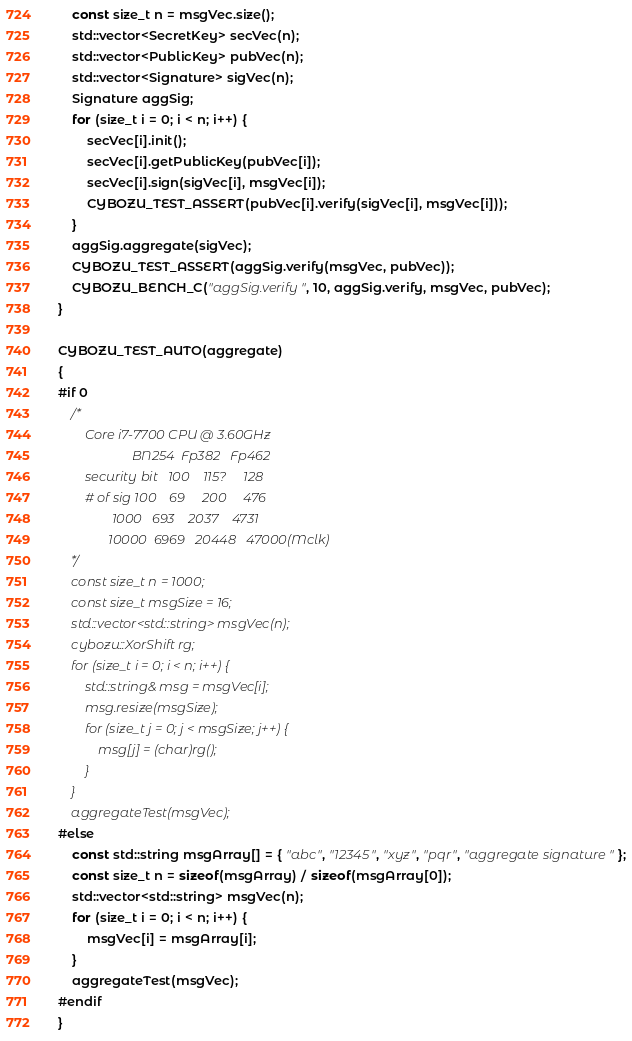<code> <loc_0><loc_0><loc_500><loc_500><_C++_>	const size_t n = msgVec.size();
	std::vector<SecretKey> secVec(n);
	std::vector<PublicKey> pubVec(n);
	std::vector<Signature> sigVec(n);
	Signature aggSig;
	for (size_t i = 0; i < n; i++) {
		secVec[i].init();
		secVec[i].getPublicKey(pubVec[i]);
		secVec[i].sign(sigVec[i], msgVec[i]);
		CYBOZU_TEST_ASSERT(pubVec[i].verify(sigVec[i], msgVec[i]));
	}
	aggSig.aggregate(sigVec);
	CYBOZU_TEST_ASSERT(aggSig.verify(msgVec, pubVec));
	CYBOZU_BENCH_C("aggSig.verify", 10, aggSig.verify, msgVec, pubVec);
}

CYBOZU_TEST_AUTO(aggregate)
{
#if 0
	/*
		Core i7-7700 CPU @ 3.60GHz
		              BN254  Fp382   Fp462
		security bit   100    115?     128
		# of sig 100    69     200     476
		        1000   693    2037    4731
		       10000  6969   20448   47000(Mclk)
	*/
	const size_t n = 1000;
	const size_t msgSize = 16;
	std::vector<std::string> msgVec(n);
	cybozu::XorShift rg;
	for (size_t i = 0; i < n; i++) {
		std::string& msg = msgVec[i];
		msg.resize(msgSize);
		for (size_t j = 0; j < msgSize; j++) {
			msg[j] = (char)rg();
		}
	}
	aggregateTest(msgVec);
#else
	const std::string msgArray[] = { "abc", "12345", "xyz", "pqr", "aggregate signature" };
	const size_t n = sizeof(msgArray) / sizeof(msgArray[0]);
	std::vector<std::string> msgVec(n);
	for (size_t i = 0; i < n; i++) {
		msgVec[i] = msgArray[i];
	}
	aggregateTest(msgVec);
#endif
}
</code> 